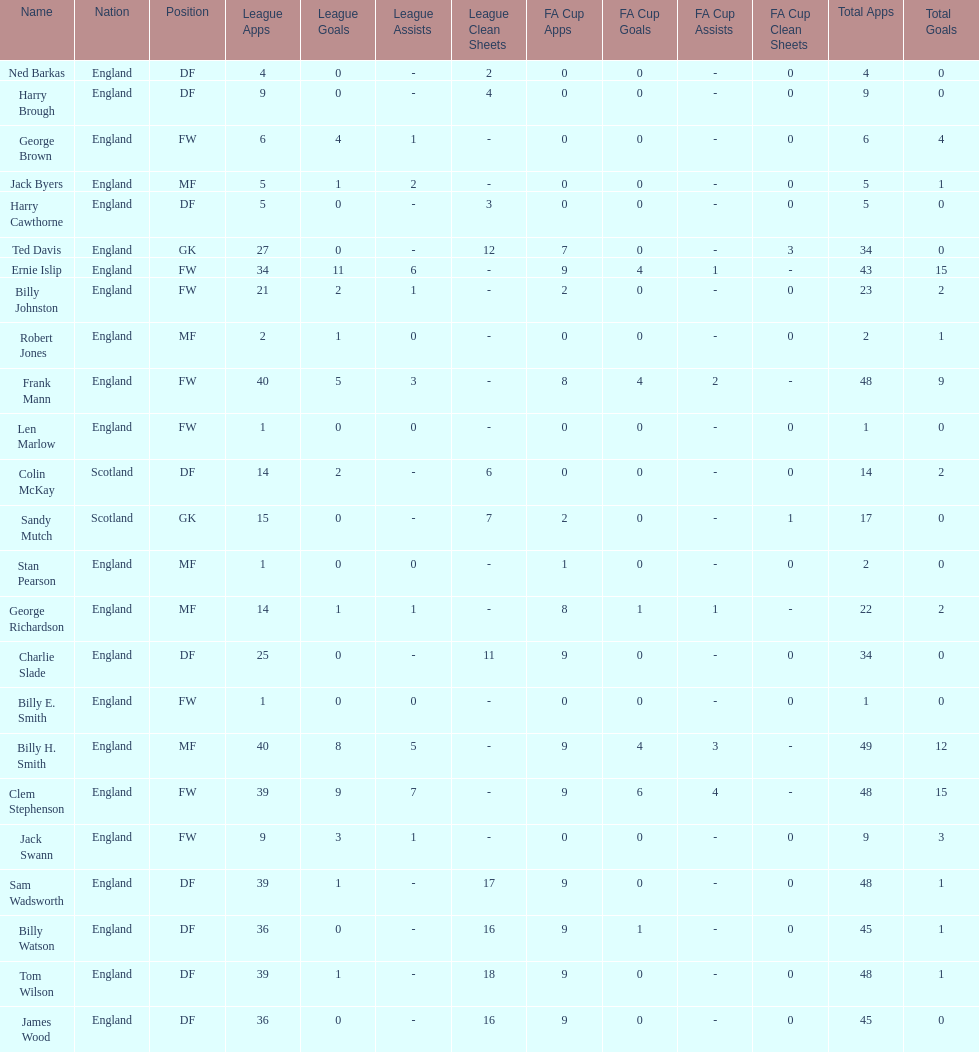What is the typical count of scotland's total apps? 15.5. 